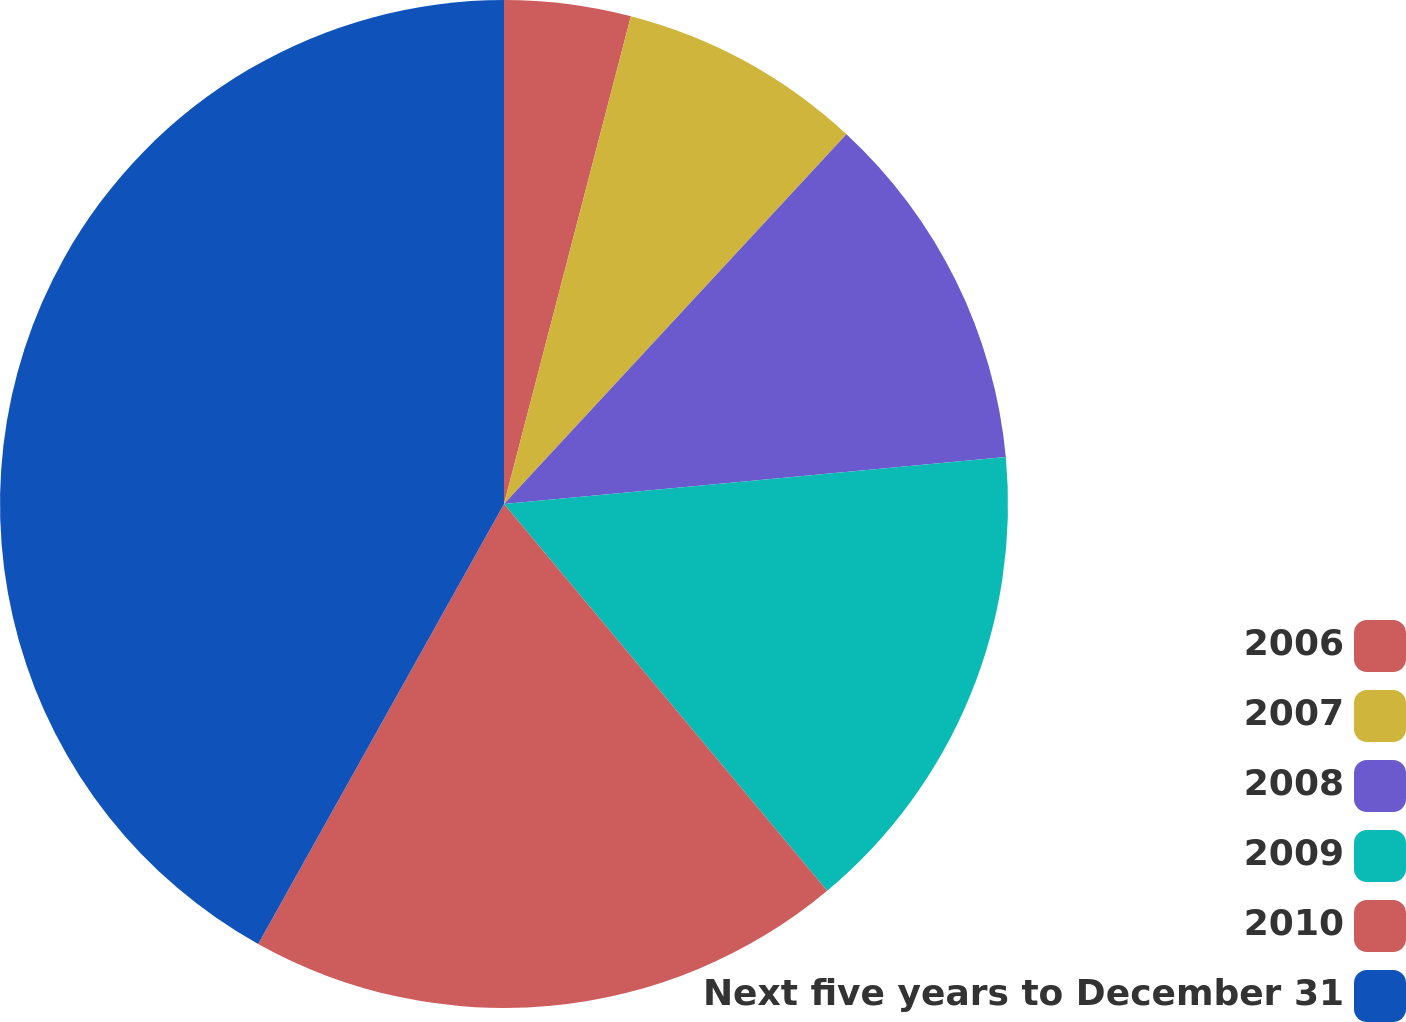<chart> <loc_0><loc_0><loc_500><loc_500><pie_chart><fcel>2006<fcel>2007<fcel>2008<fcel>2009<fcel>2010<fcel>Next five years to December 31<nl><fcel>4.05%<fcel>7.84%<fcel>11.62%<fcel>15.41%<fcel>19.19%<fcel>41.89%<nl></chart> 